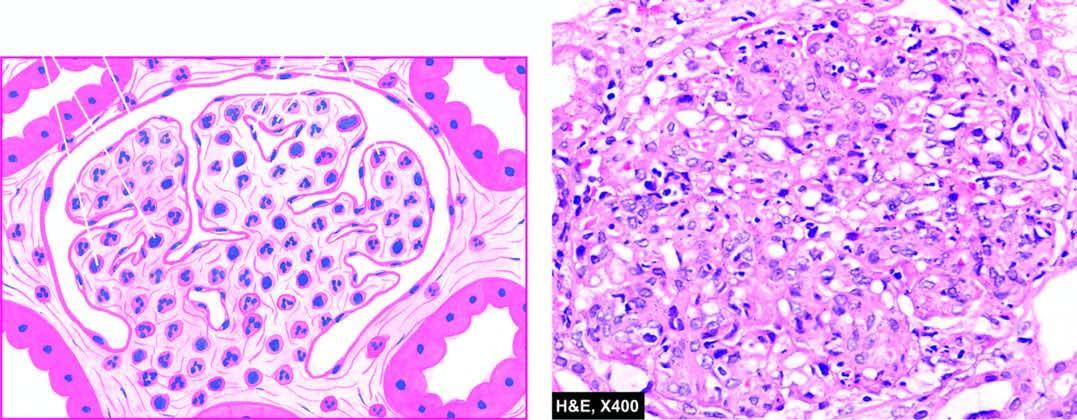s there increased cellularity due to proliferation of mesangial cels, endothelial cells and some epithelial cells and infiltration of the tuft by neutrophils and monocytes?
Answer the question using a single word or phrase. Yes 